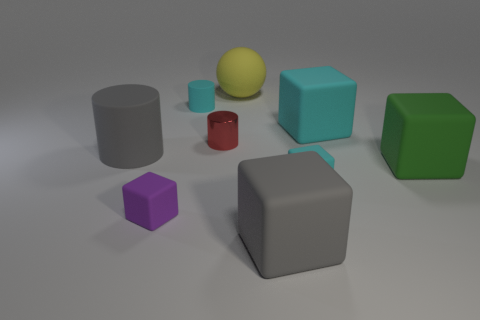There is a big thing that is in front of the yellow rubber thing and left of the big gray cube; what material is it made of?
Offer a very short reply. Rubber. Does the gray object that is behind the green block have the same material as the cyan cylinder?
Offer a terse response. Yes. What is the purple block made of?
Offer a terse response. Rubber. What size is the cyan rubber block behind the small red metallic cylinder?
Your answer should be compact. Large. Is there any other thing that is the same color as the matte ball?
Give a very brief answer. No. There is a tiny cylinder behind the metallic thing in front of the big yellow matte object; are there any small cyan matte blocks in front of it?
Provide a succinct answer. Yes. There is a large block in front of the small cyan rubber block; does it have the same color as the metallic cylinder?
Keep it short and to the point. No. What number of blocks are red metal things or big cyan objects?
Your response must be concise. 1. What is the shape of the matte thing in front of the small cube to the left of the large yellow matte object?
Offer a very short reply. Cube. There is a cyan rubber block behind the large cube to the right of the cyan rubber block that is behind the large rubber cylinder; how big is it?
Your answer should be very brief. Large. 